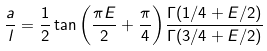Convert formula to latex. <formula><loc_0><loc_0><loc_500><loc_500>\frac { a } { l } = \frac { 1 } { 2 } \tan { \left ( \frac { \pi E } { 2 } + \frac { \pi } { 4 } \right ) } \frac { \Gamma ( 1 / 4 + E / 2 ) } { \Gamma ( 3 / 4 + E / 2 ) }</formula> 